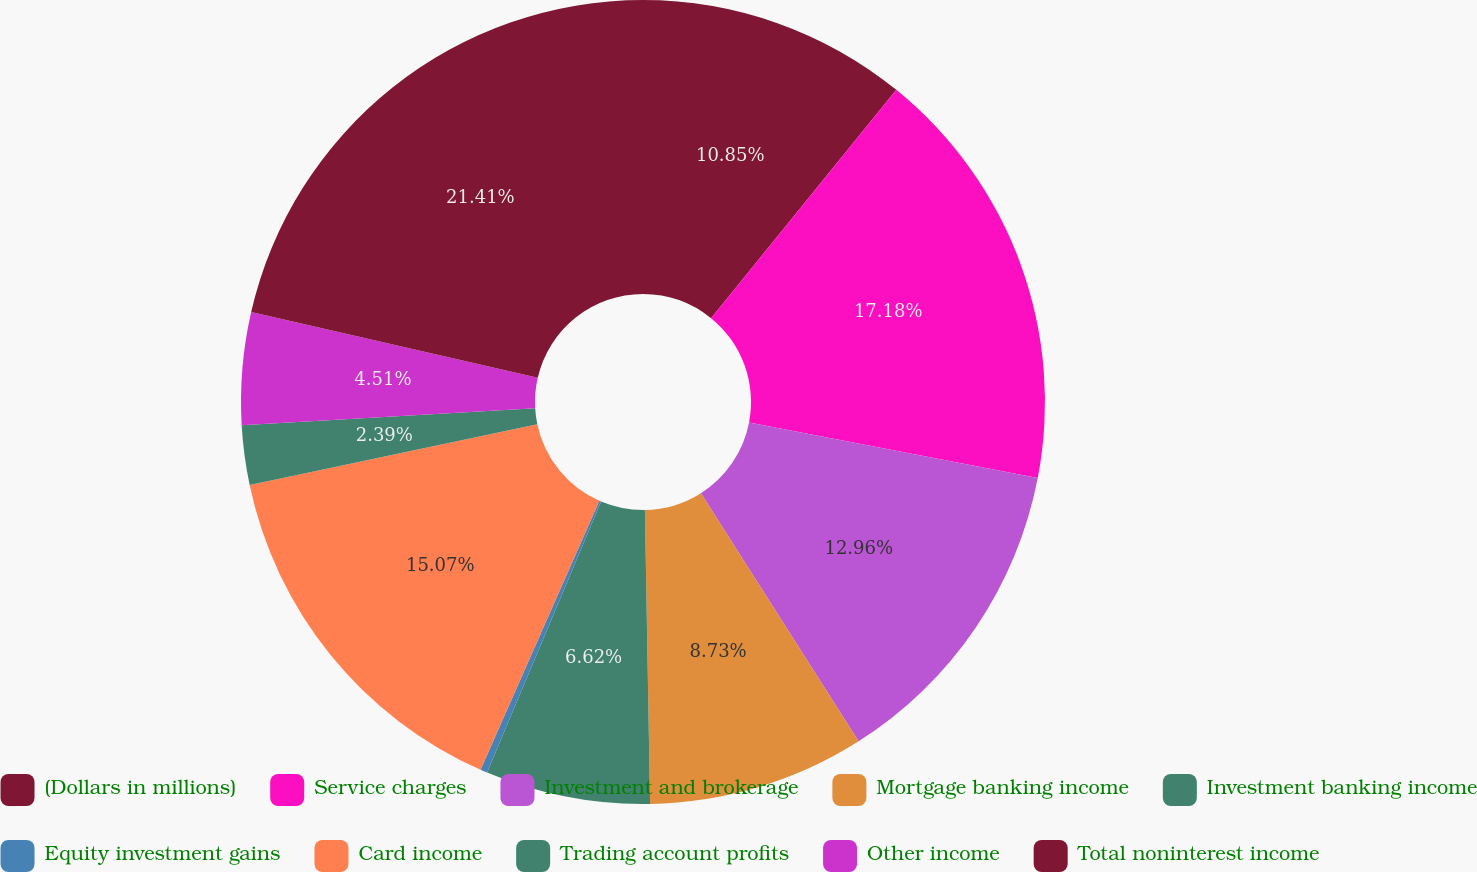<chart> <loc_0><loc_0><loc_500><loc_500><pie_chart><fcel>(Dollars in millions)<fcel>Service charges<fcel>Investment and brokerage<fcel>Mortgage banking income<fcel>Investment banking income<fcel>Equity investment gains<fcel>Card income<fcel>Trading account profits<fcel>Other income<fcel>Total noninterest income<nl><fcel>10.85%<fcel>17.18%<fcel>12.96%<fcel>8.73%<fcel>6.62%<fcel>0.28%<fcel>15.07%<fcel>2.39%<fcel>4.51%<fcel>21.41%<nl></chart> 